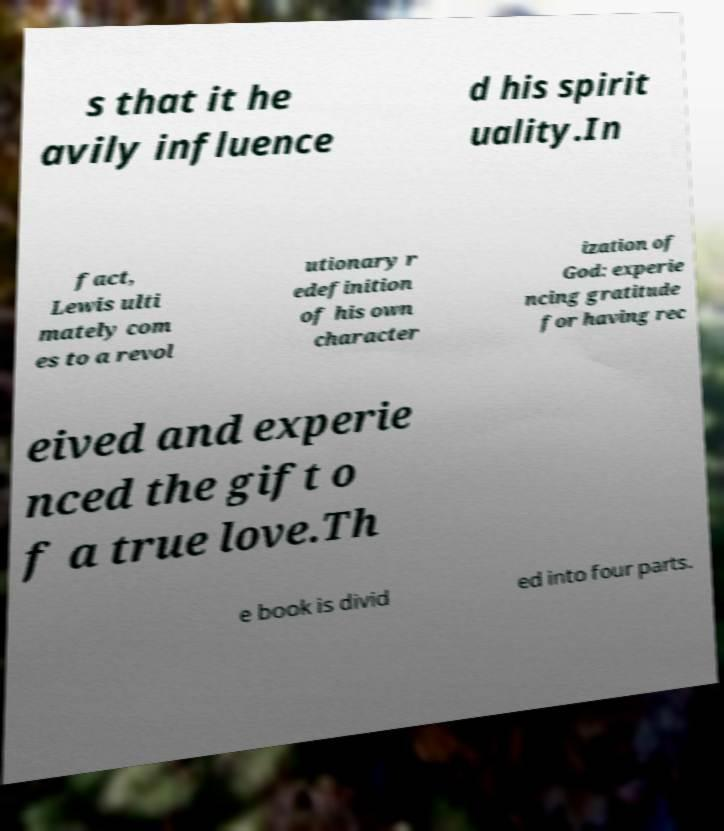I need the written content from this picture converted into text. Can you do that? s that it he avily influence d his spirit uality.In fact, Lewis ulti mately com es to a revol utionary r edefinition of his own character ization of God: experie ncing gratitude for having rec eived and experie nced the gift o f a true love.Th e book is divid ed into four parts. 